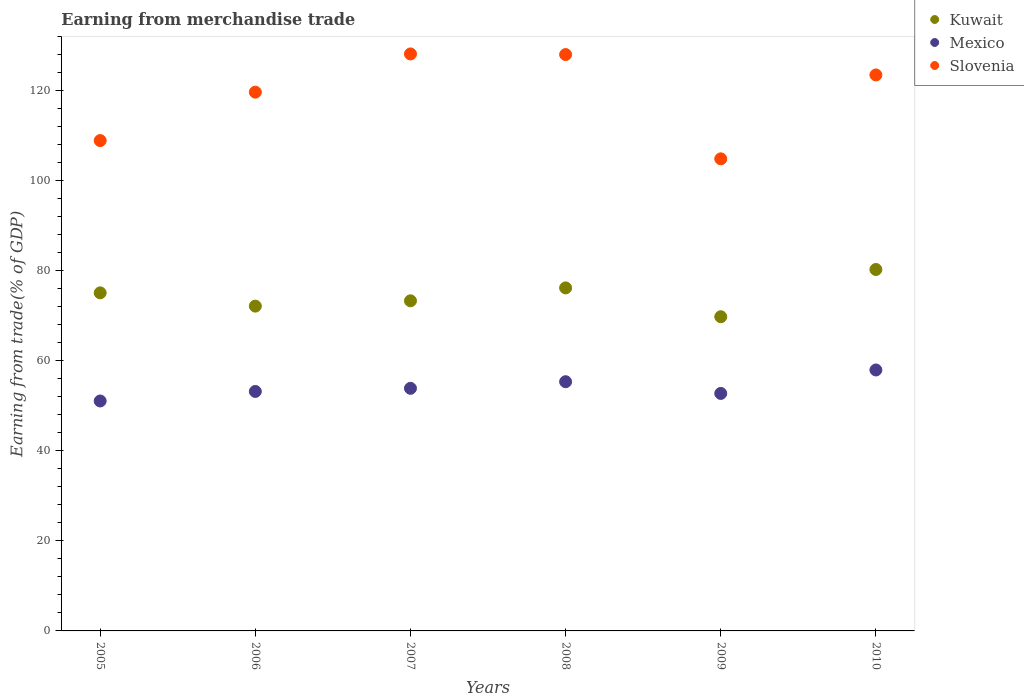Is the number of dotlines equal to the number of legend labels?
Offer a very short reply. Yes. What is the earnings from trade in Kuwait in 2006?
Offer a terse response. 72.14. Across all years, what is the maximum earnings from trade in Slovenia?
Keep it short and to the point. 128.15. Across all years, what is the minimum earnings from trade in Kuwait?
Your answer should be compact. 69.78. What is the total earnings from trade in Slovenia in the graph?
Your response must be concise. 713.08. What is the difference between the earnings from trade in Kuwait in 2006 and that in 2010?
Provide a short and direct response. -8.14. What is the difference between the earnings from trade in Mexico in 2009 and the earnings from trade in Kuwait in 2007?
Give a very brief answer. -20.57. What is the average earnings from trade in Slovenia per year?
Offer a very short reply. 118.85. In the year 2007, what is the difference between the earnings from trade in Mexico and earnings from trade in Kuwait?
Provide a short and direct response. -19.44. What is the ratio of the earnings from trade in Kuwait in 2005 to that in 2010?
Provide a succinct answer. 0.94. Is the earnings from trade in Slovenia in 2005 less than that in 2007?
Your response must be concise. Yes. Is the difference between the earnings from trade in Mexico in 2007 and 2008 greater than the difference between the earnings from trade in Kuwait in 2007 and 2008?
Your answer should be very brief. Yes. What is the difference between the highest and the second highest earnings from trade in Kuwait?
Make the answer very short. 4.09. What is the difference between the highest and the lowest earnings from trade in Slovenia?
Make the answer very short. 23.3. Does the earnings from trade in Kuwait monotonically increase over the years?
Offer a very short reply. No. Is the earnings from trade in Slovenia strictly greater than the earnings from trade in Kuwait over the years?
Ensure brevity in your answer.  Yes. What is the difference between two consecutive major ticks on the Y-axis?
Your answer should be very brief. 20. Does the graph contain any zero values?
Your response must be concise. No. Does the graph contain grids?
Offer a terse response. No. Where does the legend appear in the graph?
Keep it short and to the point. Top right. How many legend labels are there?
Provide a succinct answer. 3. How are the legend labels stacked?
Give a very brief answer. Vertical. What is the title of the graph?
Your response must be concise. Earning from merchandise trade. What is the label or title of the Y-axis?
Ensure brevity in your answer.  Earning from trade(% of GDP). What is the Earning from trade(% of GDP) in Kuwait in 2005?
Ensure brevity in your answer.  75.09. What is the Earning from trade(% of GDP) of Mexico in 2005?
Your answer should be very brief. 51.07. What is the Earning from trade(% of GDP) in Slovenia in 2005?
Keep it short and to the point. 108.91. What is the Earning from trade(% of GDP) of Kuwait in 2006?
Offer a very short reply. 72.14. What is the Earning from trade(% of GDP) in Mexico in 2006?
Make the answer very short. 53.19. What is the Earning from trade(% of GDP) in Slovenia in 2006?
Your response must be concise. 119.66. What is the Earning from trade(% of GDP) of Kuwait in 2007?
Keep it short and to the point. 73.32. What is the Earning from trade(% of GDP) of Mexico in 2007?
Offer a very short reply. 53.88. What is the Earning from trade(% of GDP) of Slovenia in 2007?
Your response must be concise. 128.15. What is the Earning from trade(% of GDP) of Kuwait in 2008?
Keep it short and to the point. 76.19. What is the Earning from trade(% of GDP) in Mexico in 2008?
Give a very brief answer. 55.35. What is the Earning from trade(% of GDP) of Slovenia in 2008?
Provide a succinct answer. 128.01. What is the Earning from trade(% of GDP) in Kuwait in 2009?
Keep it short and to the point. 69.78. What is the Earning from trade(% of GDP) in Mexico in 2009?
Provide a succinct answer. 52.75. What is the Earning from trade(% of GDP) in Slovenia in 2009?
Make the answer very short. 104.86. What is the Earning from trade(% of GDP) in Kuwait in 2010?
Provide a succinct answer. 80.28. What is the Earning from trade(% of GDP) of Mexico in 2010?
Provide a short and direct response. 57.96. What is the Earning from trade(% of GDP) of Slovenia in 2010?
Provide a succinct answer. 123.49. Across all years, what is the maximum Earning from trade(% of GDP) of Kuwait?
Offer a terse response. 80.28. Across all years, what is the maximum Earning from trade(% of GDP) in Mexico?
Your answer should be compact. 57.96. Across all years, what is the maximum Earning from trade(% of GDP) in Slovenia?
Keep it short and to the point. 128.15. Across all years, what is the minimum Earning from trade(% of GDP) of Kuwait?
Give a very brief answer. 69.78. Across all years, what is the minimum Earning from trade(% of GDP) of Mexico?
Give a very brief answer. 51.07. Across all years, what is the minimum Earning from trade(% of GDP) of Slovenia?
Your response must be concise. 104.86. What is the total Earning from trade(% of GDP) in Kuwait in the graph?
Provide a succinct answer. 446.79. What is the total Earning from trade(% of GDP) in Mexico in the graph?
Offer a terse response. 324.2. What is the total Earning from trade(% of GDP) in Slovenia in the graph?
Your answer should be compact. 713.08. What is the difference between the Earning from trade(% of GDP) in Kuwait in 2005 and that in 2006?
Your response must be concise. 2.95. What is the difference between the Earning from trade(% of GDP) of Mexico in 2005 and that in 2006?
Your answer should be compact. -2.12. What is the difference between the Earning from trade(% of GDP) in Slovenia in 2005 and that in 2006?
Provide a short and direct response. -10.75. What is the difference between the Earning from trade(% of GDP) of Kuwait in 2005 and that in 2007?
Make the answer very short. 1.77. What is the difference between the Earning from trade(% of GDP) of Mexico in 2005 and that in 2007?
Keep it short and to the point. -2.81. What is the difference between the Earning from trade(% of GDP) in Slovenia in 2005 and that in 2007?
Provide a succinct answer. -19.25. What is the difference between the Earning from trade(% of GDP) in Kuwait in 2005 and that in 2008?
Keep it short and to the point. -1.1. What is the difference between the Earning from trade(% of GDP) in Mexico in 2005 and that in 2008?
Provide a succinct answer. -4.28. What is the difference between the Earning from trade(% of GDP) of Slovenia in 2005 and that in 2008?
Provide a short and direct response. -19.11. What is the difference between the Earning from trade(% of GDP) in Kuwait in 2005 and that in 2009?
Your answer should be very brief. 5.31. What is the difference between the Earning from trade(% of GDP) in Mexico in 2005 and that in 2009?
Ensure brevity in your answer.  -1.68. What is the difference between the Earning from trade(% of GDP) in Slovenia in 2005 and that in 2009?
Provide a succinct answer. 4.05. What is the difference between the Earning from trade(% of GDP) of Kuwait in 2005 and that in 2010?
Make the answer very short. -5.19. What is the difference between the Earning from trade(% of GDP) in Mexico in 2005 and that in 2010?
Make the answer very short. -6.89. What is the difference between the Earning from trade(% of GDP) in Slovenia in 2005 and that in 2010?
Keep it short and to the point. -14.58. What is the difference between the Earning from trade(% of GDP) in Kuwait in 2006 and that in 2007?
Offer a very short reply. -1.18. What is the difference between the Earning from trade(% of GDP) of Mexico in 2006 and that in 2007?
Give a very brief answer. -0.69. What is the difference between the Earning from trade(% of GDP) in Slovenia in 2006 and that in 2007?
Give a very brief answer. -8.49. What is the difference between the Earning from trade(% of GDP) of Kuwait in 2006 and that in 2008?
Give a very brief answer. -4.05. What is the difference between the Earning from trade(% of GDP) of Mexico in 2006 and that in 2008?
Give a very brief answer. -2.16. What is the difference between the Earning from trade(% of GDP) of Slovenia in 2006 and that in 2008?
Make the answer very short. -8.35. What is the difference between the Earning from trade(% of GDP) of Kuwait in 2006 and that in 2009?
Make the answer very short. 2.36. What is the difference between the Earning from trade(% of GDP) in Mexico in 2006 and that in 2009?
Your response must be concise. 0.44. What is the difference between the Earning from trade(% of GDP) of Slovenia in 2006 and that in 2009?
Offer a terse response. 14.81. What is the difference between the Earning from trade(% of GDP) in Kuwait in 2006 and that in 2010?
Give a very brief answer. -8.14. What is the difference between the Earning from trade(% of GDP) in Mexico in 2006 and that in 2010?
Keep it short and to the point. -4.77. What is the difference between the Earning from trade(% of GDP) in Slovenia in 2006 and that in 2010?
Offer a very short reply. -3.83. What is the difference between the Earning from trade(% of GDP) in Kuwait in 2007 and that in 2008?
Provide a short and direct response. -2.87. What is the difference between the Earning from trade(% of GDP) of Mexico in 2007 and that in 2008?
Your answer should be very brief. -1.47. What is the difference between the Earning from trade(% of GDP) in Slovenia in 2007 and that in 2008?
Give a very brief answer. 0.14. What is the difference between the Earning from trade(% of GDP) of Kuwait in 2007 and that in 2009?
Keep it short and to the point. 3.54. What is the difference between the Earning from trade(% of GDP) of Mexico in 2007 and that in 2009?
Provide a succinct answer. 1.14. What is the difference between the Earning from trade(% of GDP) of Slovenia in 2007 and that in 2009?
Ensure brevity in your answer.  23.3. What is the difference between the Earning from trade(% of GDP) of Kuwait in 2007 and that in 2010?
Keep it short and to the point. -6.96. What is the difference between the Earning from trade(% of GDP) in Mexico in 2007 and that in 2010?
Offer a very short reply. -4.07. What is the difference between the Earning from trade(% of GDP) of Slovenia in 2007 and that in 2010?
Make the answer very short. 4.67. What is the difference between the Earning from trade(% of GDP) in Kuwait in 2008 and that in 2009?
Give a very brief answer. 6.4. What is the difference between the Earning from trade(% of GDP) in Mexico in 2008 and that in 2009?
Ensure brevity in your answer.  2.6. What is the difference between the Earning from trade(% of GDP) in Slovenia in 2008 and that in 2009?
Make the answer very short. 23.16. What is the difference between the Earning from trade(% of GDP) in Kuwait in 2008 and that in 2010?
Your answer should be compact. -4.09. What is the difference between the Earning from trade(% of GDP) in Mexico in 2008 and that in 2010?
Your response must be concise. -2.61. What is the difference between the Earning from trade(% of GDP) of Slovenia in 2008 and that in 2010?
Your answer should be very brief. 4.53. What is the difference between the Earning from trade(% of GDP) in Kuwait in 2009 and that in 2010?
Keep it short and to the point. -10.49. What is the difference between the Earning from trade(% of GDP) of Mexico in 2009 and that in 2010?
Provide a short and direct response. -5.21. What is the difference between the Earning from trade(% of GDP) of Slovenia in 2009 and that in 2010?
Your response must be concise. -18.63. What is the difference between the Earning from trade(% of GDP) of Kuwait in 2005 and the Earning from trade(% of GDP) of Mexico in 2006?
Provide a succinct answer. 21.9. What is the difference between the Earning from trade(% of GDP) of Kuwait in 2005 and the Earning from trade(% of GDP) of Slovenia in 2006?
Offer a terse response. -44.57. What is the difference between the Earning from trade(% of GDP) of Mexico in 2005 and the Earning from trade(% of GDP) of Slovenia in 2006?
Give a very brief answer. -68.59. What is the difference between the Earning from trade(% of GDP) of Kuwait in 2005 and the Earning from trade(% of GDP) of Mexico in 2007?
Make the answer very short. 21.21. What is the difference between the Earning from trade(% of GDP) in Kuwait in 2005 and the Earning from trade(% of GDP) in Slovenia in 2007?
Your response must be concise. -53.07. What is the difference between the Earning from trade(% of GDP) in Mexico in 2005 and the Earning from trade(% of GDP) in Slovenia in 2007?
Keep it short and to the point. -77.08. What is the difference between the Earning from trade(% of GDP) in Kuwait in 2005 and the Earning from trade(% of GDP) in Mexico in 2008?
Give a very brief answer. 19.74. What is the difference between the Earning from trade(% of GDP) in Kuwait in 2005 and the Earning from trade(% of GDP) in Slovenia in 2008?
Provide a succinct answer. -52.92. What is the difference between the Earning from trade(% of GDP) in Mexico in 2005 and the Earning from trade(% of GDP) in Slovenia in 2008?
Offer a very short reply. -76.94. What is the difference between the Earning from trade(% of GDP) of Kuwait in 2005 and the Earning from trade(% of GDP) of Mexico in 2009?
Your answer should be compact. 22.34. What is the difference between the Earning from trade(% of GDP) in Kuwait in 2005 and the Earning from trade(% of GDP) in Slovenia in 2009?
Ensure brevity in your answer.  -29.77. What is the difference between the Earning from trade(% of GDP) in Mexico in 2005 and the Earning from trade(% of GDP) in Slovenia in 2009?
Make the answer very short. -53.78. What is the difference between the Earning from trade(% of GDP) of Kuwait in 2005 and the Earning from trade(% of GDP) of Mexico in 2010?
Make the answer very short. 17.13. What is the difference between the Earning from trade(% of GDP) of Kuwait in 2005 and the Earning from trade(% of GDP) of Slovenia in 2010?
Your response must be concise. -48.4. What is the difference between the Earning from trade(% of GDP) in Mexico in 2005 and the Earning from trade(% of GDP) in Slovenia in 2010?
Provide a short and direct response. -72.42. What is the difference between the Earning from trade(% of GDP) in Kuwait in 2006 and the Earning from trade(% of GDP) in Mexico in 2007?
Your answer should be compact. 18.26. What is the difference between the Earning from trade(% of GDP) of Kuwait in 2006 and the Earning from trade(% of GDP) of Slovenia in 2007?
Make the answer very short. -56.01. What is the difference between the Earning from trade(% of GDP) in Mexico in 2006 and the Earning from trade(% of GDP) in Slovenia in 2007?
Your response must be concise. -74.96. What is the difference between the Earning from trade(% of GDP) of Kuwait in 2006 and the Earning from trade(% of GDP) of Mexico in 2008?
Offer a very short reply. 16.79. What is the difference between the Earning from trade(% of GDP) in Kuwait in 2006 and the Earning from trade(% of GDP) in Slovenia in 2008?
Keep it short and to the point. -55.87. What is the difference between the Earning from trade(% of GDP) in Mexico in 2006 and the Earning from trade(% of GDP) in Slovenia in 2008?
Offer a very short reply. -74.82. What is the difference between the Earning from trade(% of GDP) in Kuwait in 2006 and the Earning from trade(% of GDP) in Mexico in 2009?
Offer a very short reply. 19.39. What is the difference between the Earning from trade(% of GDP) in Kuwait in 2006 and the Earning from trade(% of GDP) in Slovenia in 2009?
Ensure brevity in your answer.  -32.72. What is the difference between the Earning from trade(% of GDP) of Mexico in 2006 and the Earning from trade(% of GDP) of Slovenia in 2009?
Make the answer very short. -51.66. What is the difference between the Earning from trade(% of GDP) of Kuwait in 2006 and the Earning from trade(% of GDP) of Mexico in 2010?
Ensure brevity in your answer.  14.18. What is the difference between the Earning from trade(% of GDP) of Kuwait in 2006 and the Earning from trade(% of GDP) of Slovenia in 2010?
Provide a short and direct response. -51.35. What is the difference between the Earning from trade(% of GDP) in Mexico in 2006 and the Earning from trade(% of GDP) in Slovenia in 2010?
Provide a succinct answer. -70.3. What is the difference between the Earning from trade(% of GDP) of Kuwait in 2007 and the Earning from trade(% of GDP) of Mexico in 2008?
Provide a succinct answer. 17.97. What is the difference between the Earning from trade(% of GDP) of Kuwait in 2007 and the Earning from trade(% of GDP) of Slovenia in 2008?
Ensure brevity in your answer.  -54.69. What is the difference between the Earning from trade(% of GDP) of Mexico in 2007 and the Earning from trade(% of GDP) of Slovenia in 2008?
Give a very brief answer. -74.13. What is the difference between the Earning from trade(% of GDP) of Kuwait in 2007 and the Earning from trade(% of GDP) of Mexico in 2009?
Your answer should be very brief. 20.57. What is the difference between the Earning from trade(% of GDP) of Kuwait in 2007 and the Earning from trade(% of GDP) of Slovenia in 2009?
Provide a succinct answer. -31.54. What is the difference between the Earning from trade(% of GDP) of Mexico in 2007 and the Earning from trade(% of GDP) of Slovenia in 2009?
Ensure brevity in your answer.  -50.97. What is the difference between the Earning from trade(% of GDP) in Kuwait in 2007 and the Earning from trade(% of GDP) in Mexico in 2010?
Your answer should be very brief. 15.36. What is the difference between the Earning from trade(% of GDP) of Kuwait in 2007 and the Earning from trade(% of GDP) of Slovenia in 2010?
Provide a short and direct response. -50.17. What is the difference between the Earning from trade(% of GDP) in Mexico in 2007 and the Earning from trade(% of GDP) in Slovenia in 2010?
Your answer should be very brief. -69.6. What is the difference between the Earning from trade(% of GDP) in Kuwait in 2008 and the Earning from trade(% of GDP) in Mexico in 2009?
Keep it short and to the point. 23.44. What is the difference between the Earning from trade(% of GDP) of Kuwait in 2008 and the Earning from trade(% of GDP) of Slovenia in 2009?
Provide a short and direct response. -28.67. What is the difference between the Earning from trade(% of GDP) in Mexico in 2008 and the Earning from trade(% of GDP) in Slovenia in 2009?
Keep it short and to the point. -49.5. What is the difference between the Earning from trade(% of GDP) of Kuwait in 2008 and the Earning from trade(% of GDP) of Mexico in 2010?
Offer a very short reply. 18.23. What is the difference between the Earning from trade(% of GDP) in Kuwait in 2008 and the Earning from trade(% of GDP) in Slovenia in 2010?
Make the answer very short. -47.3. What is the difference between the Earning from trade(% of GDP) in Mexico in 2008 and the Earning from trade(% of GDP) in Slovenia in 2010?
Your answer should be compact. -68.13. What is the difference between the Earning from trade(% of GDP) in Kuwait in 2009 and the Earning from trade(% of GDP) in Mexico in 2010?
Your answer should be very brief. 11.83. What is the difference between the Earning from trade(% of GDP) of Kuwait in 2009 and the Earning from trade(% of GDP) of Slovenia in 2010?
Keep it short and to the point. -53.7. What is the difference between the Earning from trade(% of GDP) of Mexico in 2009 and the Earning from trade(% of GDP) of Slovenia in 2010?
Provide a short and direct response. -70.74. What is the average Earning from trade(% of GDP) in Kuwait per year?
Your answer should be very brief. 74.47. What is the average Earning from trade(% of GDP) of Mexico per year?
Your answer should be very brief. 54.03. What is the average Earning from trade(% of GDP) of Slovenia per year?
Offer a very short reply. 118.85. In the year 2005, what is the difference between the Earning from trade(% of GDP) of Kuwait and Earning from trade(% of GDP) of Mexico?
Offer a terse response. 24.02. In the year 2005, what is the difference between the Earning from trade(% of GDP) in Kuwait and Earning from trade(% of GDP) in Slovenia?
Provide a short and direct response. -33.82. In the year 2005, what is the difference between the Earning from trade(% of GDP) of Mexico and Earning from trade(% of GDP) of Slovenia?
Ensure brevity in your answer.  -57.84. In the year 2006, what is the difference between the Earning from trade(% of GDP) in Kuwait and Earning from trade(% of GDP) in Mexico?
Make the answer very short. 18.95. In the year 2006, what is the difference between the Earning from trade(% of GDP) of Kuwait and Earning from trade(% of GDP) of Slovenia?
Provide a short and direct response. -47.52. In the year 2006, what is the difference between the Earning from trade(% of GDP) of Mexico and Earning from trade(% of GDP) of Slovenia?
Make the answer very short. -66.47. In the year 2007, what is the difference between the Earning from trade(% of GDP) in Kuwait and Earning from trade(% of GDP) in Mexico?
Provide a succinct answer. 19.44. In the year 2007, what is the difference between the Earning from trade(% of GDP) in Kuwait and Earning from trade(% of GDP) in Slovenia?
Give a very brief answer. -54.83. In the year 2007, what is the difference between the Earning from trade(% of GDP) of Mexico and Earning from trade(% of GDP) of Slovenia?
Ensure brevity in your answer.  -74.27. In the year 2008, what is the difference between the Earning from trade(% of GDP) in Kuwait and Earning from trade(% of GDP) in Mexico?
Offer a terse response. 20.84. In the year 2008, what is the difference between the Earning from trade(% of GDP) in Kuwait and Earning from trade(% of GDP) in Slovenia?
Make the answer very short. -51.83. In the year 2008, what is the difference between the Earning from trade(% of GDP) of Mexico and Earning from trade(% of GDP) of Slovenia?
Offer a terse response. -72.66. In the year 2009, what is the difference between the Earning from trade(% of GDP) in Kuwait and Earning from trade(% of GDP) in Mexico?
Offer a very short reply. 17.04. In the year 2009, what is the difference between the Earning from trade(% of GDP) of Kuwait and Earning from trade(% of GDP) of Slovenia?
Your response must be concise. -35.07. In the year 2009, what is the difference between the Earning from trade(% of GDP) of Mexico and Earning from trade(% of GDP) of Slovenia?
Your response must be concise. -52.11. In the year 2010, what is the difference between the Earning from trade(% of GDP) of Kuwait and Earning from trade(% of GDP) of Mexico?
Keep it short and to the point. 22.32. In the year 2010, what is the difference between the Earning from trade(% of GDP) of Kuwait and Earning from trade(% of GDP) of Slovenia?
Your answer should be compact. -43.21. In the year 2010, what is the difference between the Earning from trade(% of GDP) of Mexico and Earning from trade(% of GDP) of Slovenia?
Offer a very short reply. -65.53. What is the ratio of the Earning from trade(% of GDP) of Kuwait in 2005 to that in 2006?
Make the answer very short. 1.04. What is the ratio of the Earning from trade(% of GDP) in Mexico in 2005 to that in 2006?
Provide a succinct answer. 0.96. What is the ratio of the Earning from trade(% of GDP) of Slovenia in 2005 to that in 2006?
Your answer should be very brief. 0.91. What is the ratio of the Earning from trade(% of GDP) of Kuwait in 2005 to that in 2007?
Provide a succinct answer. 1.02. What is the ratio of the Earning from trade(% of GDP) of Mexico in 2005 to that in 2007?
Your answer should be compact. 0.95. What is the ratio of the Earning from trade(% of GDP) of Slovenia in 2005 to that in 2007?
Give a very brief answer. 0.85. What is the ratio of the Earning from trade(% of GDP) in Kuwait in 2005 to that in 2008?
Your answer should be compact. 0.99. What is the ratio of the Earning from trade(% of GDP) in Mexico in 2005 to that in 2008?
Offer a very short reply. 0.92. What is the ratio of the Earning from trade(% of GDP) in Slovenia in 2005 to that in 2008?
Your answer should be compact. 0.85. What is the ratio of the Earning from trade(% of GDP) in Kuwait in 2005 to that in 2009?
Offer a terse response. 1.08. What is the ratio of the Earning from trade(% of GDP) in Mexico in 2005 to that in 2009?
Your response must be concise. 0.97. What is the ratio of the Earning from trade(% of GDP) in Slovenia in 2005 to that in 2009?
Give a very brief answer. 1.04. What is the ratio of the Earning from trade(% of GDP) in Kuwait in 2005 to that in 2010?
Offer a very short reply. 0.94. What is the ratio of the Earning from trade(% of GDP) in Mexico in 2005 to that in 2010?
Your answer should be very brief. 0.88. What is the ratio of the Earning from trade(% of GDP) of Slovenia in 2005 to that in 2010?
Your response must be concise. 0.88. What is the ratio of the Earning from trade(% of GDP) in Kuwait in 2006 to that in 2007?
Ensure brevity in your answer.  0.98. What is the ratio of the Earning from trade(% of GDP) of Mexico in 2006 to that in 2007?
Provide a short and direct response. 0.99. What is the ratio of the Earning from trade(% of GDP) in Slovenia in 2006 to that in 2007?
Make the answer very short. 0.93. What is the ratio of the Earning from trade(% of GDP) of Kuwait in 2006 to that in 2008?
Give a very brief answer. 0.95. What is the ratio of the Earning from trade(% of GDP) of Slovenia in 2006 to that in 2008?
Provide a short and direct response. 0.93. What is the ratio of the Earning from trade(% of GDP) in Kuwait in 2006 to that in 2009?
Make the answer very short. 1.03. What is the ratio of the Earning from trade(% of GDP) of Mexico in 2006 to that in 2009?
Provide a succinct answer. 1.01. What is the ratio of the Earning from trade(% of GDP) of Slovenia in 2006 to that in 2009?
Give a very brief answer. 1.14. What is the ratio of the Earning from trade(% of GDP) in Kuwait in 2006 to that in 2010?
Offer a very short reply. 0.9. What is the ratio of the Earning from trade(% of GDP) of Mexico in 2006 to that in 2010?
Your response must be concise. 0.92. What is the ratio of the Earning from trade(% of GDP) of Kuwait in 2007 to that in 2008?
Your answer should be compact. 0.96. What is the ratio of the Earning from trade(% of GDP) of Mexico in 2007 to that in 2008?
Offer a very short reply. 0.97. What is the ratio of the Earning from trade(% of GDP) of Slovenia in 2007 to that in 2008?
Give a very brief answer. 1. What is the ratio of the Earning from trade(% of GDP) in Kuwait in 2007 to that in 2009?
Make the answer very short. 1.05. What is the ratio of the Earning from trade(% of GDP) of Mexico in 2007 to that in 2009?
Provide a succinct answer. 1.02. What is the ratio of the Earning from trade(% of GDP) in Slovenia in 2007 to that in 2009?
Make the answer very short. 1.22. What is the ratio of the Earning from trade(% of GDP) in Kuwait in 2007 to that in 2010?
Ensure brevity in your answer.  0.91. What is the ratio of the Earning from trade(% of GDP) in Mexico in 2007 to that in 2010?
Provide a succinct answer. 0.93. What is the ratio of the Earning from trade(% of GDP) in Slovenia in 2007 to that in 2010?
Make the answer very short. 1.04. What is the ratio of the Earning from trade(% of GDP) in Kuwait in 2008 to that in 2009?
Make the answer very short. 1.09. What is the ratio of the Earning from trade(% of GDP) in Mexico in 2008 to that in 2009?
Offer a very short reply. 1.05. What is the ratio of the Earning from trade(% of GDP) of Slovenia in 2008 to that in 2009?
Ensure brevity in your answer.  1.22. What is the ratio of the Earning from trade(% of GDP) of Kuwait in 2008 to that in 2010?
Ensure brevity in your answer.  0.95. What is the ratio of the Earning from trade(% of GDP) in Mexico in 2008 to that in 2010?
Your answer should be compact. 0.95. What is the ratio of the Earning from trade(% of GDP) of Slovenia in 2008 to that in 2010?
Your response must be concise. 1.04. What is the ratio of the Earning from trade(% of GDP) of Kuwait in 2009 to that in 2010?
Provide a short and direct response. 0.87. What is the ratio of the Earning from trade(% of GDP) in Mexico in 2009 to that in 2010?
Offer a terse response. 0.91. What is the ratio of the Earning from trade(% of GDP) of Slovenia in 2009 to that in 2010?
Provide a short and direct response. 0.85. What is the difference between the highest and the second highest Earning from trade(% of GDP) in Kuwait?
Keep it short and to the point. 4.09. What is the difference between the highest and the second highest Earning from trade(% of GDP) in Mexico?
Provide a short and direct response. 2.61. What is the difference between the highest and the second highest Earning from trade(% of GDP) of Slovenia?
Your response must be concise. 0.14. What is the difference between the highest and the lowest Earning from trade(% of GDP) of Kuwait?
Ensure brevity in your answer.  10.49. What is the difference between the highest and the lowest Earning from trade(% of GDP) in Mexico?
Your answer should be very brief. 6.89. What is the difference between the highest and the lowest Earning from trade(% of GDP) in Slovenia?
Your response must be concise. 23.3. 